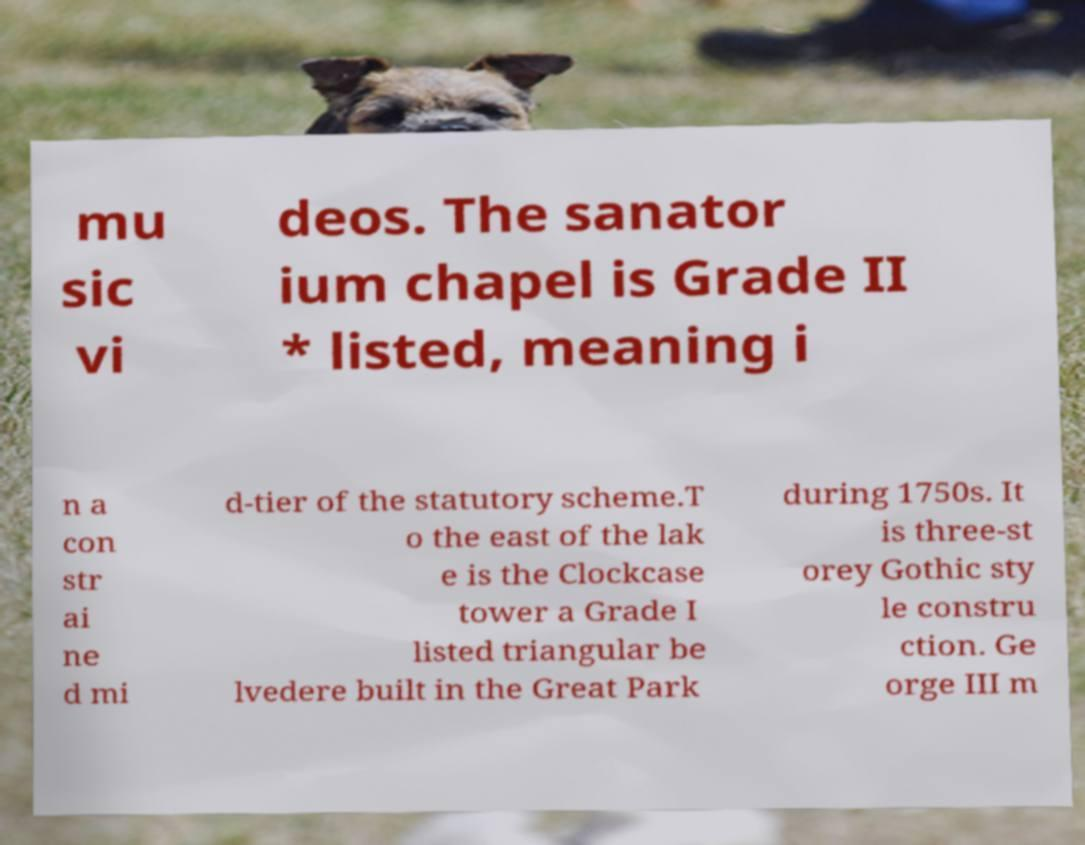Could you extract and type out the text from this image? mu sic vi deos. The sanator ium chapel is Grade II * listed, meaning i n a con str ai ne d mi d-tier of the statutory scheme.T o the east of the lak e is the Clockcase tower a Grade I listed triangular be lvedere built in the Great Park during 1750s. It is three-st orey Gothic sty le constru ction. Ge orge III m 